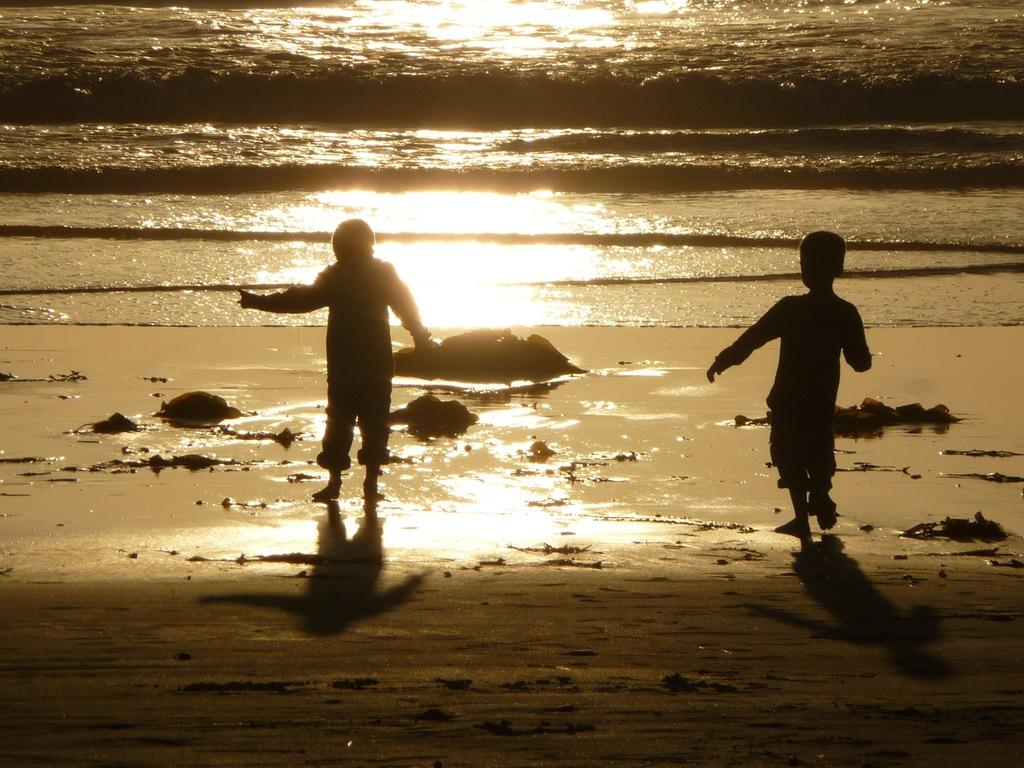How many children are in the image? There are two children in the image. What are the children doing in the image? The children are walking on the sand. What can be seen in the background of the image? There is water visible in the background of the image. What is the source of light in the image? Sunlight is present in the image. Where is the cellar located in the image? There is no cellar present in the image. Can you see an airplane flying in the sky in the image? There is no airplane visible in the image. 